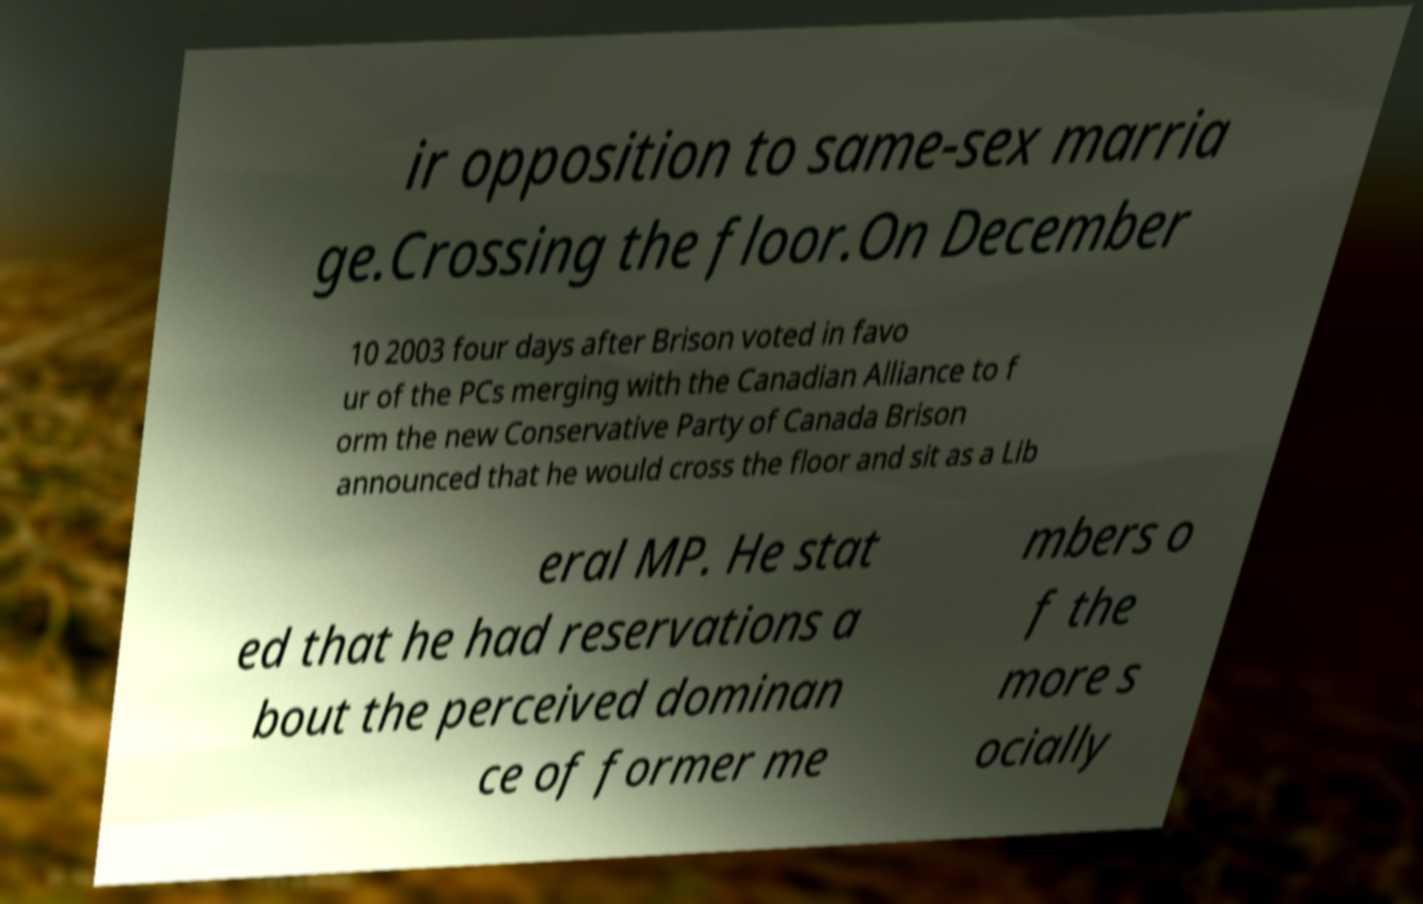Could you assist in decoding the text presented in this image and type it out clearly? ir opposition to same-sex marria ge.Crossing the floor.On December 10 2003 four days after Brison voted in favo ur of the PCs merging with the Canadian Alliance to f orm the new Conservative Party of Canada Brison announced that he would cross the floor and sit as a Lib eral MP. He stat ed that he had reservations a bout the perceived dominan ce of former me mbers o f the more s ocially 